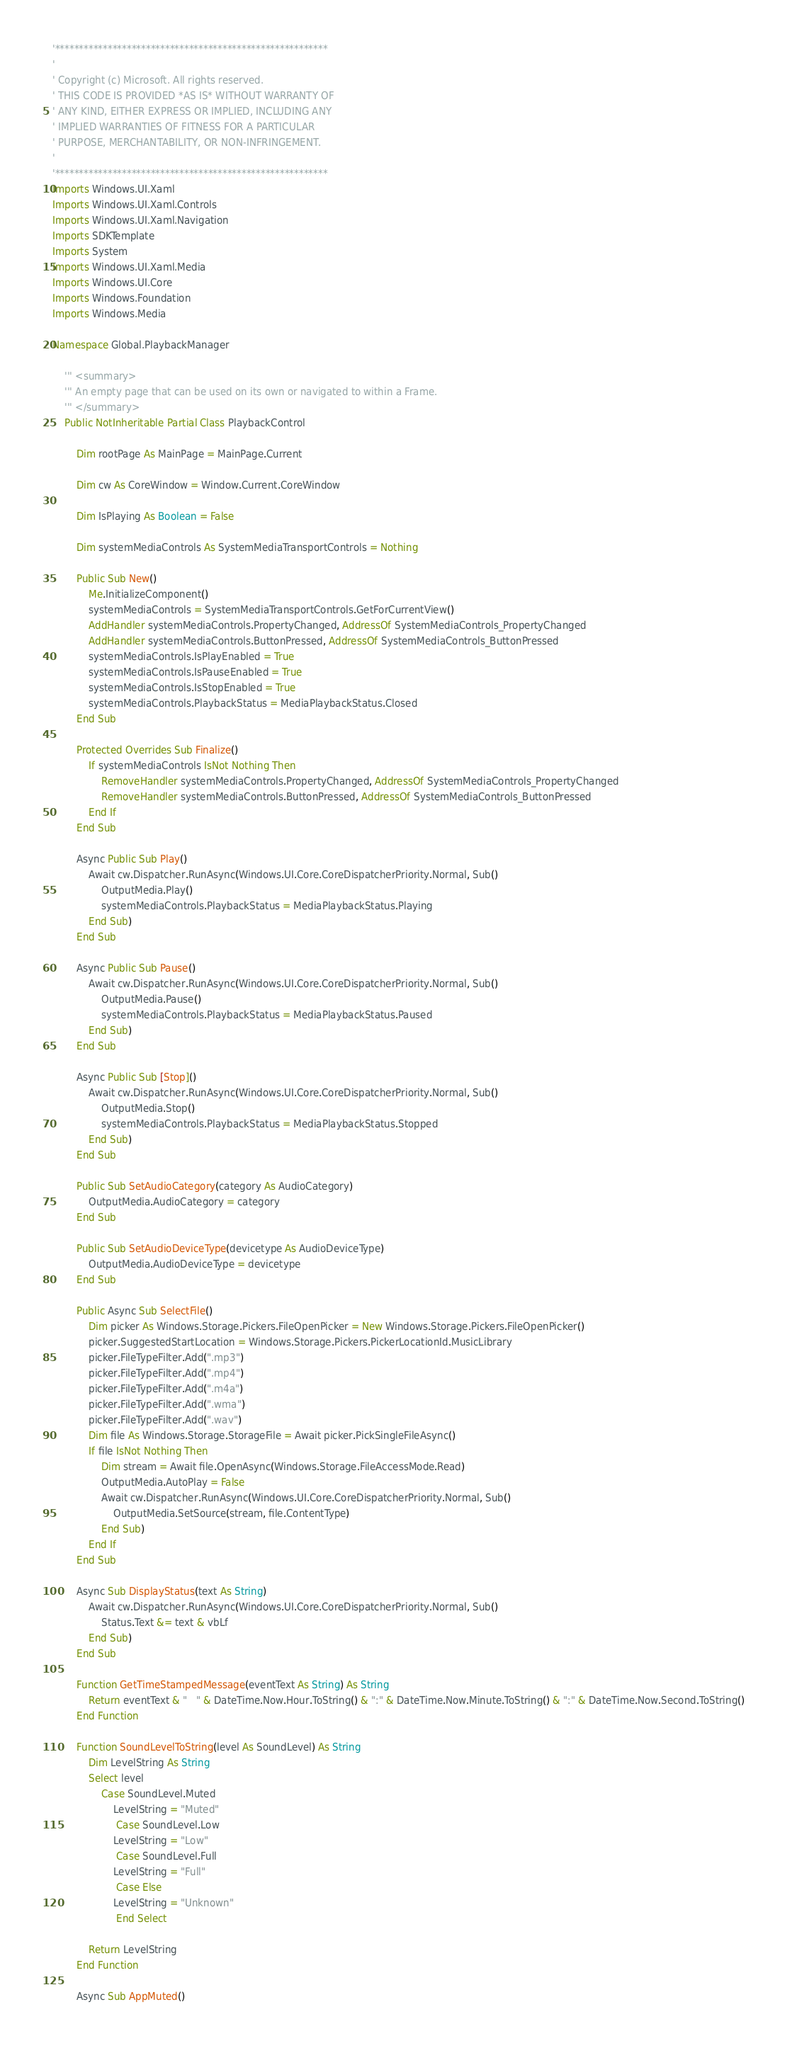<code> <loc_0><loc_0><loc_500><loc_500><_VisualBasic_>'*********************************************************
'
' Copyright (c) Microsoft. All rights reserved.
' THIS CODE IS PROVIDED *AS IS* WITHOUT WARRANTY OF
' ANY KIND, EITHER EXPRESS OR IMPLIED, INCLUDING ANY
' IMPLIED WARRANTIES OF FITNESS FOR A PARTICULAR
' PURPOSE, MERCHANTABILITY, OR NON-INFRINGEMENT.
'
'*********************************************************
Imports Windows.UI.Xaml
Imports Windows.UI.Xaml.Controls
Imports Windows.UI.Xaml.Navigation
Imports SDKTemplate
Imports System
Imports Windows.UI.Xaml.Media
Imports Windows.UI.Core
Imports Windows.Foundation
Imports Windows.Media

Namespace Global.PlaybackManager

    ''' <summary>
    ''' An empty page that can be used on its own or navigated to within a Frame.
    ''' </summary>
    Public NotInheritable Partial Class PlaybackControl

        Dim rootPage As MainPage = MainPage.Current

        Dim cw As CoreWindow = Window.Current.CoreWindow

        Dim IsPlaying As Boolean = False

        Dim systemMediaControls As SystemMediaTransportControls = Nothing

        Public Sub New()
            Me.InitializeComponent()
            systemMediaControls = SystemMediaTransportControls.GetForCurrentView()
            AddHandler systemMediaControls.PropertyChanged, AddressOf SystemMediaControls_PropertyChanged
            AddHandler systemMediaControls.ButtonPressed, AddressOf SystemMediaControls_ButtonPressed
            systemMediaControls.IsPlayEnabled = True
            systemMediaControls.IsPauseEnabled = True
            systemMediaControls.IsStopEnabled = True
            systemMediaControls.PlaybackStatus = MediaPlaybackStatus.Closed
        End Sub

        Protected Overrides Sub Finalize()
            If systemMediaControls IsNot Nothing Then
                RemoveHandler systemMediaControls.PropertyChanged, AddressOf SystemMediaControls_PropertyChanged
                RemoveHandler systemMediaControls.ButtonPressed, AddressOf SystemMediaControls_ButtonPressed
            End If
        End Sub

        Async Public Sub Play()
            Await cw.Dispatcher.RunAsync(Windows.UI.Core.CoreDispatcherPriority.Normal, Sub()
                OutputMedia.Play()
                systemMediaControls.PlaybackStatus = MediaPlaybackStatus.Playing
            End Sub)
        End Sub

        Async Public Sub Pause()
            Await cw.Dispatcher.RunAsync(Windows.UI.Core.CoreDispatcherPriority.Normal, Sub()
                OutputMedia.Pause()
                systemMediaControls.PlaybackStatus = MediaPlaybackStatus.Paused
            End Sub)
        End Sub

        Async Public Sub [Stop]()
            Await cw.Dispatcher.RunAsync(Windows.UI.Core.CoreDispatcherPriority.Normal, Sub()
                OutputMedia.Stop()
                systemMediaControls.PlaybackStatus = MediaPlaybackStatus.Stopped
            End Sub)
        End Sub

        Public Sub SetAudioCategory(category As AudioCategory)
            OutputMedia.AudioCategory = category
        End Sub

        Public Sub SetAudioDeviceType(devicetype As AudioDeviceType)
            OutputMedia.AudioDeviceType = devicetype
        End Sub

        Public Async Sub SelectFile()
            Dim picker As Windows.Storage.Pickers.FileOpenPicker = New Windows.Storage.Pickers.FileOpenPicker()
            picker.SuggestedStartLocation = Windows.Storage.Pickers.PickerLocationId.MusicLibrary
            picker.FileTypeFilter.Add(".mp3")
            picker.FileTypeFilter.Add(".mp4")
            picker.FileTypeFilter.Add(".m4a")
            picker.FileTypeFilter.Add(".wma")
            picker.FileTypeFilter.Add(".wav")
            Dim file As Windows.Storage.StorageFile = Await picker.PickSingleFileAsync()
            If file IsNot Nothing Then
                Dim stream = Await file.OpenAsync(Windows.Storage.FileAccessMode.Read)
                OutputMedia.AutoPlay = False
                Await cw.Dispatcher.RunAsync(Windows.UI.Core.CoreDispatcherPriority.Normal, Sub()
                    OutputMedia.SetSource(stream, file.ContentType)
                End Sub)
            End If
        End Sub

        Async Sub DisplayStatus(text As String)
            Await cw.Dispatcher.RunAsync(Windows.UI.Core.CoreDispatcherPriority.Normal, Sub()
                Status.Text &= text & vbLf
            End Sub)
        End Sub

        Function GetTimeStampedMessage(eventText As String) As String
            Return eventText & "   " & DateTime.Now.Hour.ToString() & ":" & DateTime.Now.Minute.ToString() & ":" & DateTime.Now.Second.ToString()
        End Function

        Function SoundLevelToString(level As SoundLevel) As String
            Dim LevelString As String
            Select level
                Case SoundLevel.Muted
                    LevelString = "Muted"
                     Case SoundLevel.Low
                    LevelString = "Low"
                     Case SoundLevel.Full
                    LevelString = "Full"
                     Case Else
                    LevelString = "Unknown"
                     End Select

            Return LevelString
        End Function

        Async Sub AppMuted()</code> 